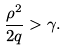Convert formula to latex. <formula><loc_0><loc_0><loc_500><loc_500>\frac { \rho ^ { 2 } } { 2 q } > \gamma .</formula> 